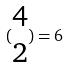<formula> <loc_0><loc_0><loc_500><loc_500>( \begin{matrix} 4 \\ 2 \end{matrix} ) = 6</formula> 